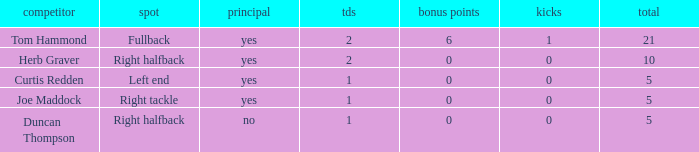Name the starter for position being left end Yes. 